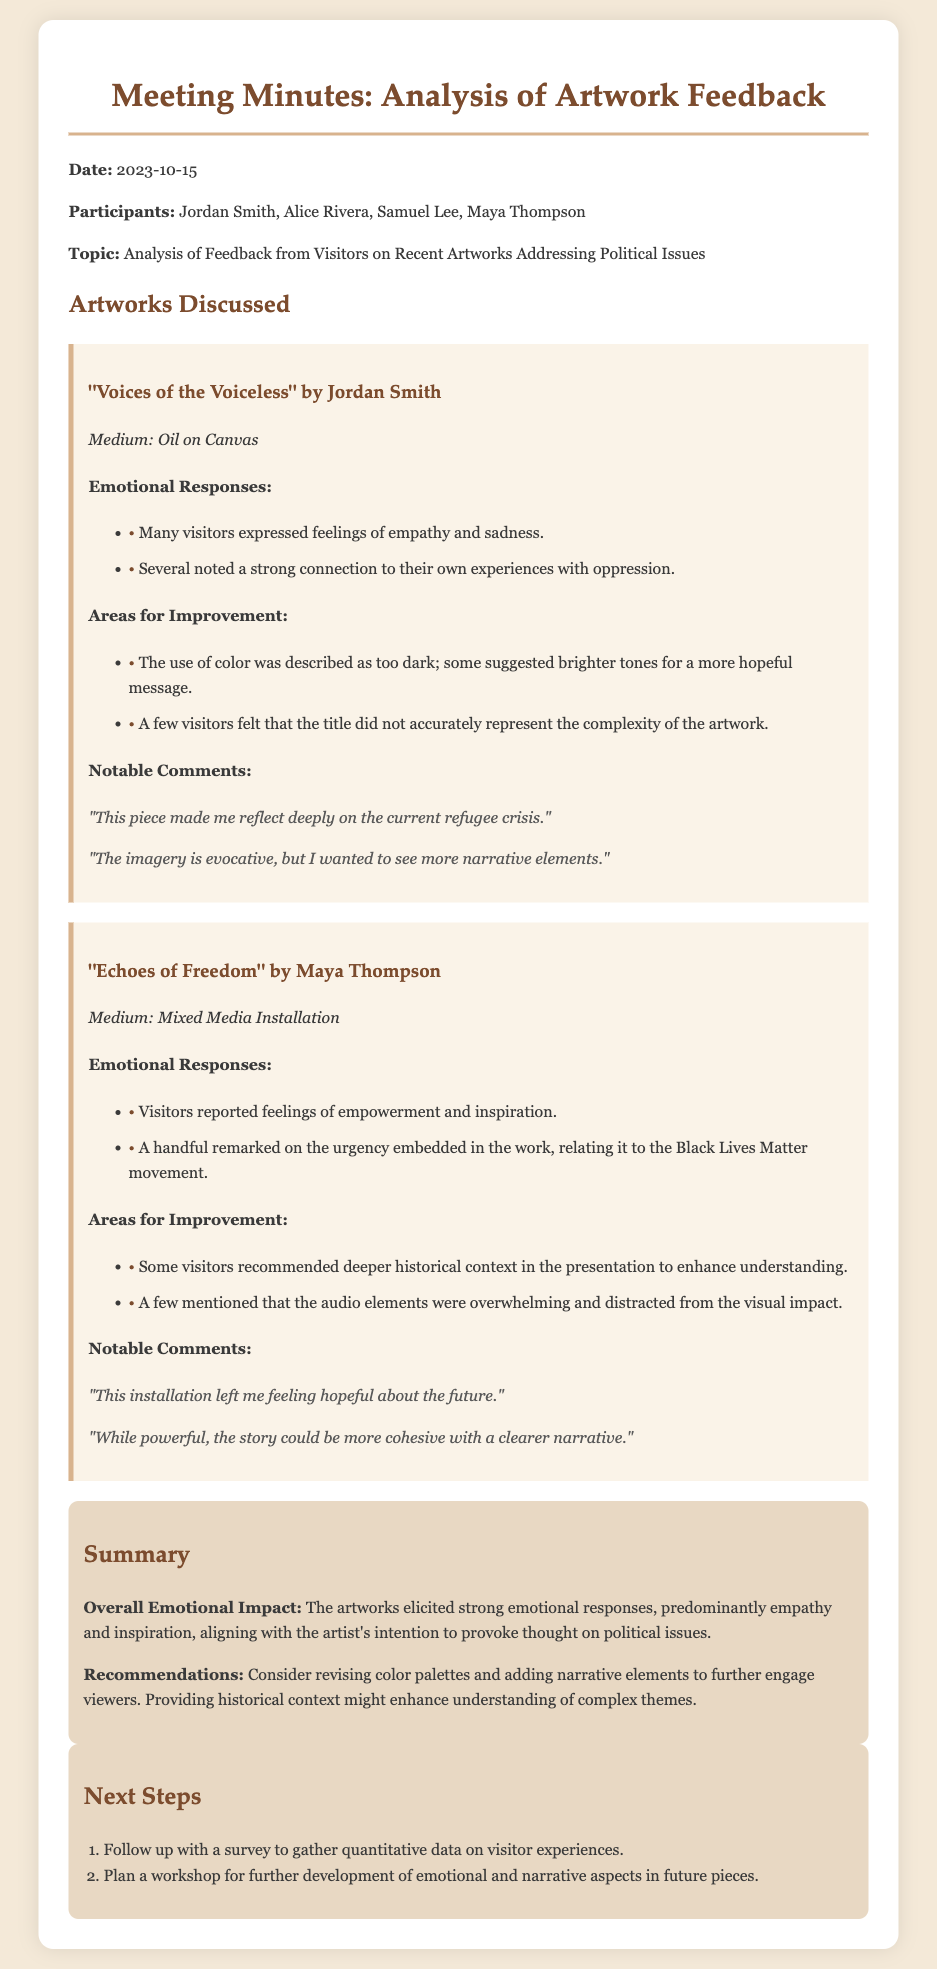what was the date of the meeting? The date of the meeting is stated at the beginning of the document.
Answer: 2023-10-15 who created "Voices of the Voiceless"? The creator of "Voices of the Voiceless" is mentioned in the section discussing the artwork.
Answer: Jordan Smith what was a notable comment about "Echoes of Freedom"? The document includes notable comments that express visitors' reactions to "Echoes of Freedom."
Answer: "This installation left me feeling hopeful about the future." what emotion was primarily elicited by "Voices of the Voiceless"? The document outlines emotional responses to the artworks, mentioning specific feelings.
Answer: Empathy what recommendation was made for future artworks? The document contains a summary section that includes recommendations for improvements in future artworks.
Answer: Revising color palettes what is the medium of "Echoes of Freedom"? The document provides information about the medium used in "Echoes of Freedom."
Answer: Mixed Media Installation how many participants were at the meeting? The participants present at the meeting are listed in the document.
Answer: Four what did some visitors suggest about the color used in "Voices of the Voiceless"? Feedback on "Voices of the Voiceless" addressed specific aspects of the artwork, including color.
Answer: Brighter tones for a more hopeful message 